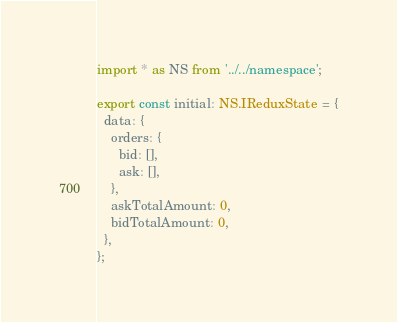<code> <loc_0><loc_0><loc_500><loc_500><_TypeScript_>import * as NS from '../../namespace';

export const initial: NS.IReduxState = {
  data: {
    orders: {
      bid: [],
      ask: [],
    },
    askTotalAmount: 0,
    bidTotalAmount: 0,
  },
};
</code> 